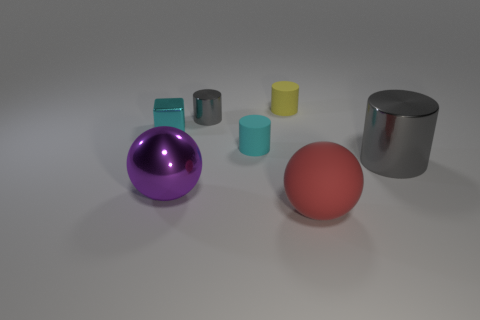Add 3 small cyan rubber things. How many objects exist? 10 Subtract all blocks. How many objects are left? 6 Add 6 large purple matte cylinders. How many large purple matte cylinders exist? 6 Subtract 0 yellow balls. How many objects are left? 7 Subtract all gray metal cylinders. Subtract all red matte things. How many objects are left? 4 Add 3 large purple spheres. How many large purple spheres are left? 4 